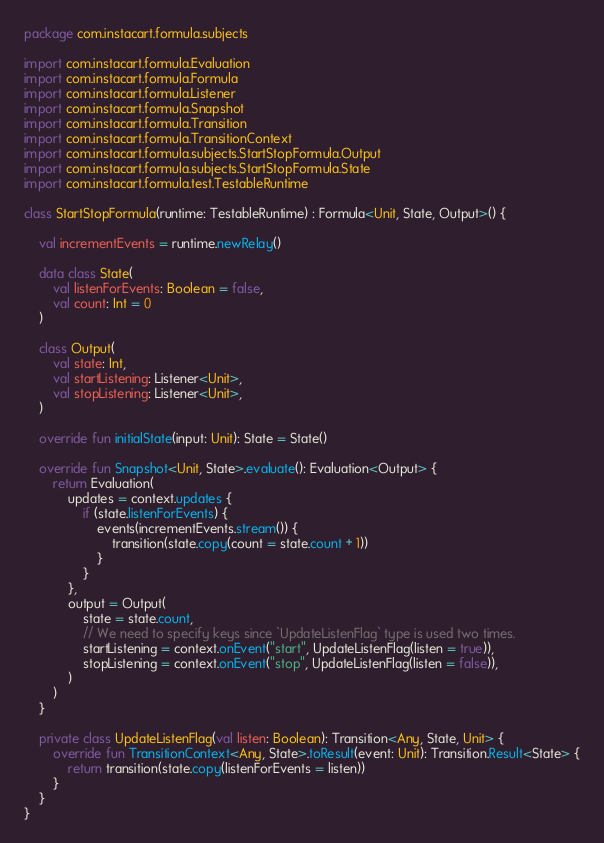<code> <loc_0><loc_0><loc_500><loc_500><_Kotlin_>package com.instacart.formula.subjects

import com.instacart.formula.Evaluation
import com.instacart.formula.Formula
import com.instacart.formula.Listener
import com.instacart.formula.Snapshot
import com.instacart.formula.Transition
import com.instacart.formula.TransitionContext
import com.instacart.formula.subjects.StartStopFormula.Output
import com.instacart.formula.subjects.StartStopFormula.State
import com.instacart.formula.test.TestableRuntime

class StartStopFormula(runtime: TestableRuntime) : Formula<Unit, State, Output>() {

    val incrementEvents = runtime.newRelay()

    data class State(
        val listenForEvents: Boolean = false,
        val count: Int = 0
    )

    class Output(
        val state: Int,
        val startListening: Listener<Unit>,
        val stopListening: Listener<Unit>,
    )

    override fun initialState(input: Unit): State = State()

    override fun Snapshot<Unit, State>.evaluate(): Evaluation<Output> {
        return Evaluation(
            updates = context.updates {
                if (state.listenForEvents) {
                    events(incrementEvents.stream()) {
                        transition(state.copy(count = state.count + 1))
                    }
                }
            },
            output = Output(
                state = state.count,
                // We need to specify keys since `UpdateListenFlag` type is used two times.
                startListening = context.onEvent("start", UpdateListenFlag(listen = true)),
                stopListening = context.onEvent("stop", UpdateListenFlag(listen = false)),
            )
        )
    }

    private class UpdateListenFlag(val listen: Boolean): Transition<Any, State, Unit> {
        override fun TransitionContext<Any, State>.toResult(event: Unit): Transition.Result<State> {
            return transition(state.copy(listenForEvents = listen))
        }
    }
}
</code> 